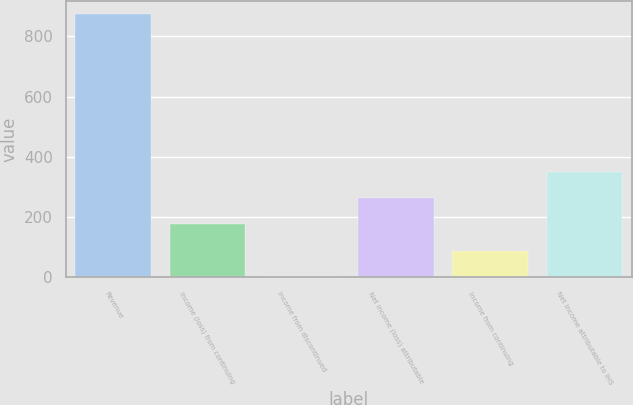Convert chart. <chart><loc_0><loc_0><loc_500><loc_500><bar_chart><fcel>Revenue<fcel>Income (loss) from continuing<fcel>Income from discontinued<fcel>Net income (loss) attributable<fcel>Income from continuing<fcel>Net income attributable to IHS<nl><fcel>873.8<fcel>175.72<fcel>1.2<fcel>262.98<fcel>88.46<fcel>350.24<nl></chart> 